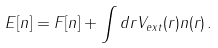Convert formula to latex. <formula><loc_0><loc_0><loc_500><loc_500>E [ n ] = F [ n ] + \int d { r } V _ { e x t } ( { r } ) n ( { r } ) \, .</formula> 